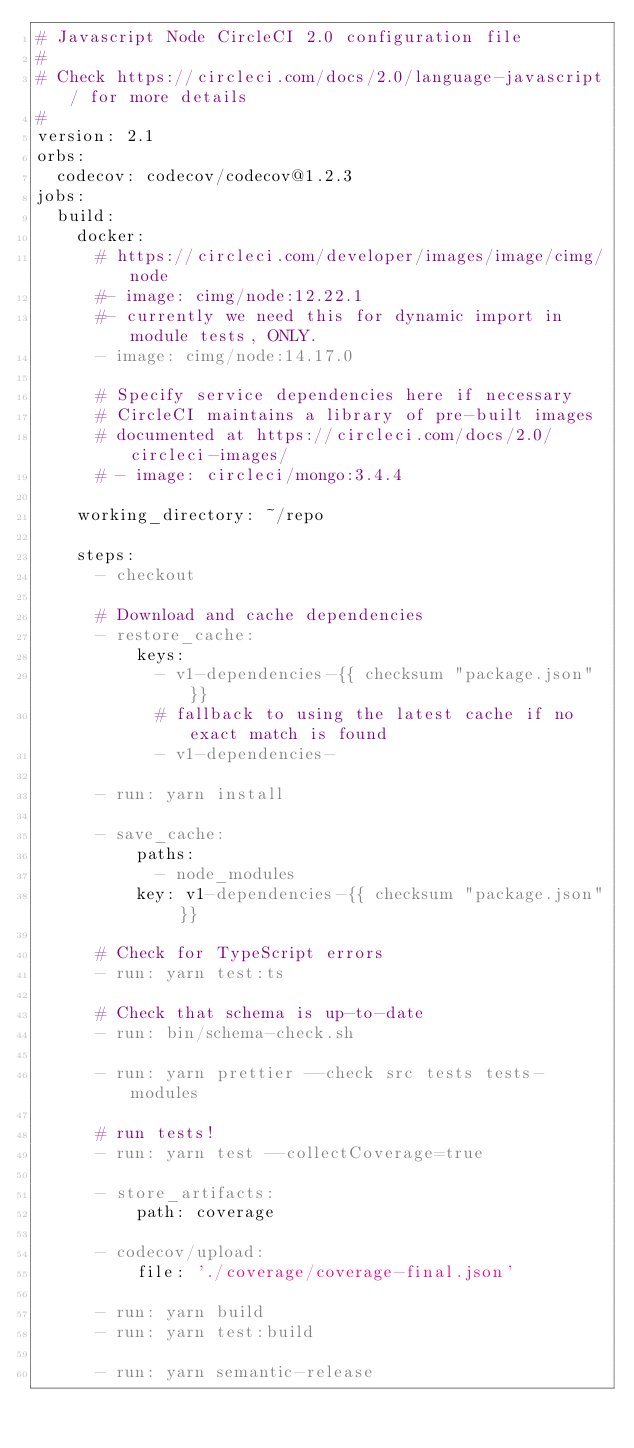Convert code to text. <code><loc_0><loc_0><loc_500><loc_500><_YAML_># Javascript Node CircleCI 2.0 configuration file
#
# Check https://circleci.com/docs/2.0/language-javascript/ for more details
#
version: 2.1
orbs:
  codecov: codecov/codecov@1.2.3
jobs:
  build:
    docker:
      # https://circleci.com/developer/images/image/cimg/node
      #- image: cimg/node:12.22.1
      #- currently we need this for dynamic import in module tests, ONLY.
      - image: cimg/node:14.17.0

      # Specify service dependencies here if necessary
      # CircleCI maintains a library of pre-built images
      # documented at https://circleci.com/docs/2.0/circleci-images/
      # - image: circleci/mongo:3.4.4

    working_directory: ~/repo

    steps:
      - checkout

      # Download and cache dependencies
      - restore_cache:
          keys:
            - v1-dependencies-{{ checksum "package.json" }}
            # fallback to using the latest cache if no exact match is found
            - v1-dependencies-

      - run: yarn install

      - save_cache:
          paths:
            - node_modules
          key: v1-dependencies-{{ checksum "package.json" }}

      # Check for TypeScript errors
      - run: yarn test:ts

      # Check that schema is up-to-date
      - run: bin/schema-check.sh

      - run: yarn prettier --check src tests tests-modules

      # run tests!
      - run: yarn test --collectCoverage=true

      - store_artifacts:
          path: coverage

      - codecov/upload:
          file: './coverage/coverage-final.json'

      - run: yarn build
      - run: yarn test:build

      - run: yarn semantic-release
</code> 